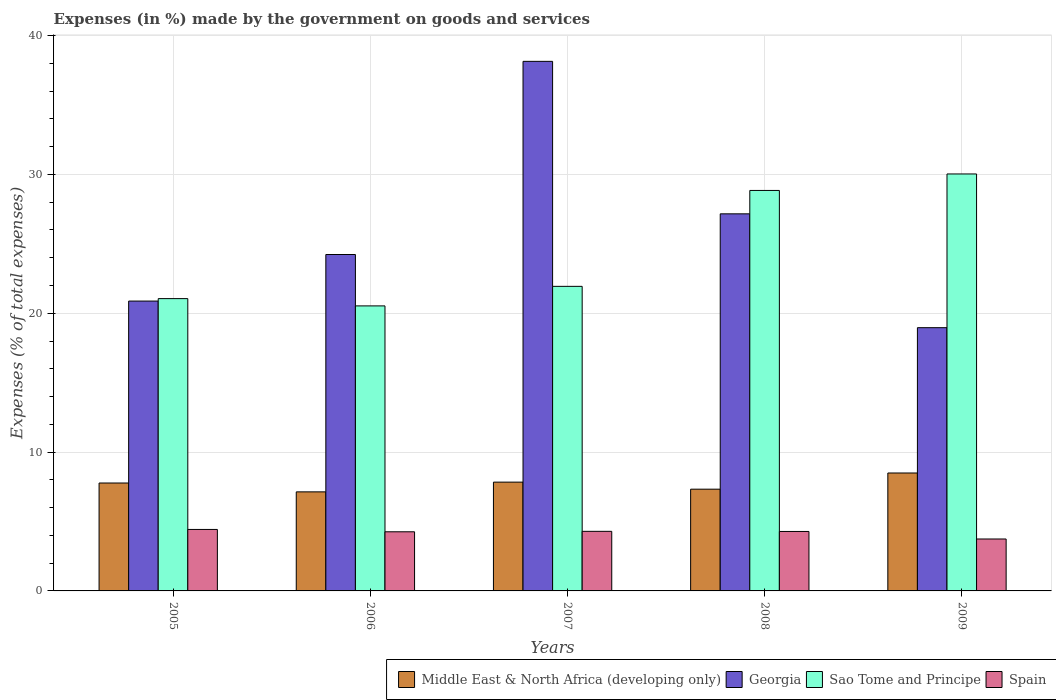How many different coloured bars are there?
Keep it short and to the point. 4. How many bars are there on the 4th tick from the left?
Ensure brevity in your answer.  4. What is the label of the 3rd group of bars from the left?
Your response must be concise. 2007. What is the percentage of expenses made by the government on goods and services in Spain in 2006?
Ensure brevity in your answer.  4.26. Across all years, what is the maximum percentage of expenses made by the government on goods and services in Spain?
Provide a succinct answer. 4.43. Across all years, what is the minimum percentage of expenses made by the government on goods and services in Sao Tome and Principe?
Your answer should be very brief. 20.53. In which year was the percentage of expenses made by the government on goods and services in Georgia maximum?
Keep it short and to the point. 2007. What is the total percentage of expenses made by the government on goods and services in Georgia in the graph?
Offer a terse response. 129.37. What is the difference between the percentage of expenses made by the government on goods and services in Georgia in 2005 and that in 2009?
Give a very brief answer. 1.92. What is the difference between the percentage of expenses made by the government on goods and services in Middle East & North Africa (developing only) in 2008 and the percentage of expenses made by the government on goods and services in Spain in 2006?
Give a very brief answer. 3.07. What is the average percentage of expenses made by the government on goods and services in Middle East & North Africa (developing only) per year?
Your answer should be very brief. 7.71. In the year 2008, what is the difference between the percentage of expenses made by the government on goods and services in Georgia and percentage of expenses made by the government on goods and services in Spain?
Ensure brevity in your answer.  22.88. In how many years, is the percentage of expenses made by the government on goods and services in Sao Tome and Principe greater than 20 %?
Keep it short and to the point. 5. What is the ratio of the percentage of expenses made by the government on goods and services in Middle East & North Africa (developing only) in 2007 to that in 2008?
Provide a short and direct response. 1.07. Is the percentage of expenses made by the government on goods and services in Middle East & North Africa (developing only) in 2005 less than that in 2007?
Your answer should be compact. Yes. What is the difference between the highest and the second highest percentage of expenses made by the government on goods and services in Spain?
Provide a succinct answer. 0.14. What is the difference between the highest and the lowest percentage of expenses made by the government on goods and services in Georgia?
Provide a short and direct response. 19.18. Is the sum of the percentage of expenses made by the government on goods and services in Middle East & North Africa (developing only) in 2007 and 2009 greater than the maximum percentage of expenses made by the government on goods and services in Sao Tome and Principe across all years?
Your response must be concise. No. What does the 1st bar from the left in 2008 represents?
Offer a very short reply. Middle East & North Africa (developing only). What does the 3rd bar from the right in 2007 represents?
Offer a terse response. Georgia. Does the graph contain grids?
Provide a short and direct response. Yes. Where does the legend appear in the graph?
Provide a short and direct response. Bottom right. How are the legend labels stacked?
Your response must be concise. Horizontal. What is the title of the graph?
Your answer should be compact. Expenses (in %) made by the government on goods and services. What is the label or title of the Y-axis?
Offer a terse response. Expenses (% of total expenses). What is the Expenses (% of total expenses) of Middle East & North Africa (developing only) in 2005?
Your answer should be very brief. 7.77. What is the Expenses (% of total expenses) of Georgia in 2005?
Keep it short and to the point. 20.88. What is the Expenses (% of total expenses) in Sao Tome and Principe in 2005?
Ensure brevity in your answer.  21.05. What is the Expenses (% of total expenses) of Spain in 2005?
Offer a very short reply. 4.43. What is the Expenses (% of total expenses) of Middle East & North Africa (developing only) in 2006?
Give a very brief answer. 7.13. What is the Expenses (% of total expenses) in Georgia in 2006?
Ensure brevity in your answer.  24.23. What is the Expenses (% of total expenses) in Sao Tome and Principe in 2006?
Keep it short and to the point. 20.53. What is the Expenses (% of total expenses) of Spain in 2006?
Keep it short and to the point. 4.26. What is the Expenses (% of total expenses) in Middle East & North Africa (developing only) in 2007?
Offer a very short reply. 7.84. What is the Expenses (% of total expenses) in Georgia in 2007?
Keep it short and to the point. 38.14. What is the Expenses (% of total expenses) of Sao Tome and Principe in 2007?
Your answer should be compact. 21.94. What is the Expenses (% of total expenses) in Spain in 2007?
Provide a succinct answer. 4.29. What is the Expenses (% of total expenses) in Middle East & North Africa (developing only) in 2008?
Your response must be concise. 7.33. What is the Expenses (% of total expenses) of Georgia in 2008?
Your response must be concise. 27.16. What is the Expenses (% of total expenses) in Sao Tome and Principe in 2008?
Keep it short and to the point. 28.85. What is the Expenses (% of total expenses) of Spain in 2008?
Keep it short and to the point. 4.28. What is the Expenses (% of total expenses) in Middle East & North Africa (developing only) in 2009?
Provide a short and direct response. 8.49. What is the Expenses (% of total expenses) in Georgia in 2009?
Make the answer very short. 18.96. What is the Expenses (% of total expenses) of Sao Tome and Principe in 2009?
Offer a terse response. 30.03. What is the Expenses (% of total expenses) of Spain in 2009?
Provide a succinct answer. 3.74. Across all years, what is the maximum Expenses (% of total expenses) in Middle East & North Africa (developing only)?
Offer a terse response. 8.49. Across all years, what is the maximum Expenses (% of total expenses) in Georgia?
Your answer should be very brief. 38.14. Across all years, what is the maximum Expenses (% of total expenses) of Sao Tome and Principe?
Offer a terse response. 30.03. Across all years, what is the maximum Expenses (% of total expenses) of Spain?
Offer a very short reply. 4.43. Across all years, what is the minimum Expenses (% of total expenses) of Middle East & North Africa (developing only)?
Provide a short and direct response. 7.13. Across all years, what is the minimum Expenses (% of total expenses) in Georgia?
Your answer should be very brief. 18.96. Across all years, what is the minimum Expenses (% of total expenses) of Sao Tome and Principe?
Offer a very short reply. 20.53. Across all years, what is the minimum Expenses (% of total expenses) of Spain?
Offer a very short reply. 3.74. What is the total Expenses (% of total expenses) in Middle East & North Africa (developing only) in the graph?
Offer a very short reply. 38.57. What is the total Expenses (% of total expenses) in Georgia in the graph?
Provide a short and direct response. 129.37. What is the total Expenses (% of total expenses) in Sao Tome and Principe in the graph?
Offer a terse response. 122.4. What is the total Expenses (% of total expenses) of Spain in the graph?
Your answer should be very brief. 21. What is the difference between the Expenses (% of total expenses) of Middle East & North Africa (developing only) in 2005 and that in 2006?
Offer a terse response. 0.64. What is the difference between the Expenses (% of total expenses) of Georgia in 2005 and that in 2006?
Your response must be concise. -3.35. What is the difference between the Expenses (% of total expenses) of Sao Tome and Principe in 2005 and that in 2006?
Your answer should be very brief. 0.52. What is the difference between the Expenses (% of total expenses) of Spain in 2005 and that in 2006?
Your answer should be very brief. 0.17. What is the difference between the Expenses (% of total expenses) in Middle East & North Africa (developing only) in 2005 and that in 2007?
Your answer should be very brief. -0.06. What is the difference between the Expenses (% of total expenses) in Georgia in 2005 and that in 2007?
Keep it short and to the point. -17.27. What is the difference between the Expenses (% of total expenses) in Sao Tome and Principe in 2005 and that in 2007?
Offer a very short reply. -0.88. What is the difference between the Expenses (% of total expenses) in Spain in 2005 and that in 2007?
Provide a succinct answer. 0.14. What is the difference between the Expenses (% of total expenses) in Middle East & North Africa (developing only) in 2005 and that in 2008?
Give a very brief answer. 0.44. What is the difference between the Expenses (% of total expenses) in Georgia in 2005 and that in 2008?
Your answer should be compact. -6.28. What is the difference between the Expenses (% of total expenses) of Sao Tome and Principe in 2005 and that in 2008?
Offer a terse response. -7.79. What is the difference between the Expenses (% of total expenses) in Spain in 2005 and that in 2008?
Your response must be concise. 0.15. What is the difference between the Expenses (% of total expenses) of Middle East & North Africa (developing only) in 2005 and that in 2009?
Offer a terse response. -0.72. What is the difference between the Expenses (% of total expenses) in Georgia in 2005 and that in 2009?
Offer a terse response. 1.92. What is the difference between the Expenses (% of total expenses) of Sao Tome and Principe in 2005 and that in 2009?
Your answer should be compact. -8.98. What is the difference between the Expenses (% of total expenses) of Spain in 2005 and that in 2009?
Offer a terse response. 0.69. What is the difference between the Expenses (% of total expenses) of Middle East & North Africa (developing only) in 2006 and that in 2007?
Your answer should be compact. -0.7. What is the difference between the Expenses (% of total expenses) of Georgia in 2006 and that in 2007?
Your answer should be very brief. -13.91. What is the difference between the Expenses (% of total expenses) of Sao Tome and Principe in 2006 and that in 2007?
Ensure brevity in your answer.  -1.41. What is the difference between the Expenses (% of total expenses) in Spain in 2006 and that in 2007?
Offer a very short reply. -0.03. What is the difference between the Expenses (% of total expenses) in Middle East & North Africa (developing only) in 2006 and that in 2008?
Make the answer very short. -0.19. What is the difference between the Expenses (% of total expenses) in Georgia in 2006 and that in 2008?
Ensure brevity in your answer.  -2.93. What is the difference between the Expenses (% of total expenses) in Sao Tome and Principe in 2006 and that in 2008?
Provide a short and direct response. -8.32. What is the difference between the Expenses (% of total expenses) in Spain in 2006 and that in 2008?
Keep it short and to the point. -0.02. What is the difference between the Expenses (% of total expenses) of Middle East & North Africa (developing only) in 2006 and that in 2009?
Keep it short and to the point. -1.36. What is the difference between the Expenses (% of total expenses) of Georgia in 2006 and that in 2009?
Your answer should be very brief. 5.27. What is the difference between the Expenses (% of total expenses) in Sao Tome and Principe in 2006 and that in 2009?
Give a very brief answer. -9.5. What is the difference between the Expenses (% of total expenses) in Spain in 2006 and that in 2009?
Your answer should be very brief. 0.52. What is the difference between the Expenses (% of total expenses) in Middle East & North Africa (developing only) in 2007 and that in 2008?
Ensure brevity in your answer.  0.51. What is the difference between the Expenses (% of total expenses) of Georgia in 2007 and that in 2008?
Your answer should be compact. 10.98. What is the difference between the Expenses (% of total expenses) of Sao Tome and Principe in 2007 and that in 2008?
Offer a terse response. -6.91. What is the difference between the Expenses (% of total expenses) in Spain in 2007 and that in 2008?
Your response must be concise. 0.01. What is the difference between the Expenses (% of total expenses) of Middle East & North Africa (developing only) in 2007 and that in 2009?
Ensure brevity in your answer.  -0.66. What is the difference between the Expenses (% of total expenses) of Georgia in 2007 and that in 2009?
Your answer should be very brief. 19.18. What is the difference between the Expenses (% of total expenses) in Sao Tome and Principe in 2007 and that in 2009?
Keep it short and to the point. -8.1. What is the difference between the Expenses (% of total expenses) in Spain in 2007 and that in 2009?
Ensure brevity in your answer.  0.55. What is the difference between the Expenses (% of total expenses) in Middle East & North Africa (developing only) in 2008 and that in 2009?
Your answer should be very brief. -1.17. What is the difference between the Expenses (% of total expenses) of Georgia in 2008 and that in 2009?
Give a very brief answer. 8.2. What is the difference between the Expenses (% of total expenses) in Sao Tome and Principe in 2008 and that in 2009?
Your answer should be compact. -1.19. What is the difference between the Expenses (% of total expenses) of Spain in 2008 and that in 2009?
Ensure brevity in your answer.  0.54. What is the difference between the Expenses (% of total expenses) in Middle East & North Africa (developing only) in 2005 and the Expenses (% of total expenses) in Georgia in 2006?
Offer a very short reply. -16.46. What is the difference between the Expenses (% of total expenses) in Middle East & North Africa (developing only) in 2005 and the Expenses (% of total expenses) in Sao Tome and Principe in 2006?
Give a very brief answer. -12.76. What is the difference between the Expenses (% of total expenses) of Middle East & North Africa (developing only) in 2005 and the Expenses (% of total expenses) of Spain in 2006?
Keep it short and to the point. 3.51. What is the difference between the Expenses (% of total expenses) in Georgia in 2005 and the Expenses (% of total expenses) in Sao Tome and Principe in 2006?
Provide a short and direct response. 0.35. What is the difference between the Expenses (% of total expenses) in Georgia in 2005 and the Expenses (% of total expenses) in Spain in 2006?
Offer a very short reply. 16.62. What is the difference between the Expenses (% of total expenses) in Sao Tome and Principe in 2005 and the Expenses (% of total expenses) in Spain in 2006?
Offer a very short reply. 16.8. What is the difference between the Expenses (% of total expenses) of Middle East & North Africa (developing only) in 2005 and the Expenses (% of total expenses) of Georgia in 2007?
Offer a very short reply. -30.37. What is the difference between the Expenses (% of total expenses) in Middle East & North Africa (developing only) in 2005 and the Expenses (% of total expenses) in Sao Tome and Principe in 2007?
Your answer should be very brief. -14.16. What is the difference between the Expenses (% of total expenses) of Middle East & North Africa (developing only) in 2005 and the Expenses (% of total expenses) of Spain in 2007?
Make the answer very short. 3.48. What is the difference between the Expenses (% of total expenses) in Georgia in 2005 and the Expenses (% of total expenses) in Sao Tome and Principe in 2007?
Provide a short and direct response. -1.06. What is the difference between the Expenses (% of total expenses) in Georgia in 2005 and the Expenses (% of total expenses) in Spain in 2007?
Provide a short and direct response. 16.59. What is the difference between the Expenses (% of total expenses) of Sao Tome and Principe in 2005 and the Expenses (% of total expenses) of Spain in 2007?
Ensure brevity in your answer.  16.76. What is the difference between the Expenses (% of total expenses) in Middle East & North Africa (developing only) in 2005 and the Expenses (% of total expenses) in Georgia in 2008?
Keep it short and to the point. -19.39. What is the difference between the Expenses (% of total expenses) in Middle East & North Africa (developing only) in 2005 and the Expenses (% of total expenses) in Sao Tome and Principe in 2008?
Offer a terse response. -21.07. What is the difference between the Expenses (% of total expenses) of Middle East & North Africa (developing only) in 2005 and the Expenses (% of total expenses) of Spain in 2008?
Your response must be concise. 3.49. What is the difference between the Expenses (% of total expenses) of Georgia in 2005 and the Expenses (% of total expenses) of Sao Tome and Principe in 2008?
Provide a succinct answer. -7.97. What is the difference between the Expenses (% of total expenses) of Georgia in 2005 and the Expenses (% of total expenses) of Spain in 2008?
Your answer should be very brief. 16.59. What is the difference between the Expenses (% of total expenses) of Sao Tome and Principe in 2005 and the Expenses (% of total expenses) of Spain in 2008?
Provide a succinct answer. 16.77. What is the difference between the Expenses (% of total expenses) of Middle East & North Africa (developing only) in 2005 and the Expenses (% of total expenses) of Georgia in 2009?
Give a very brief answer. -11.19. What is the difference between the Expenses (% of total expenses) in Middle East & North Africa (developing only) in 2005 and the Expenses (% of total expenses) in Sao Tome and Principe in 2009?
Provide a succinct answer. -22.26. What is the difference between the Expenses (% of total expenses) of Middle East & North Africa (developing only) in 2005 and the Expenses (% of total expenses) of Spain in 2009?
Give a very brief answer. 4.03. What is the difference between the Expenses (% of total expenses) in Georgia in 2005 and the Expenses (% of total expenses) in Sao Tome and Principe in 2009?
Offer a very short reply. -9.16. What is the difference between the Expenses (% of total expenses) in Georgia in 2005 and the Expenses (% of total expenses) in Spain in 2009?
Provide a succinct answer. 17.14. What is the difference between the Expenses (% of total expenses) in Sao Tome and Principe in 2005 and the Expenses (% of total expenses) in Spain in 2009?
Ensure brevity in your answer.  17.31. What is the difference between the Expenses (% of total expenses) of Middle East & North Africa (developing only) in 2006 and the Expenses (% of total expenses) of Georgia in 2007?
Give a very brief answer. -31.01. What is the difference between the Expenses (% of total expenses) in Middle East & North Africa (developing only) in 2006 and the Expenses (% of total expenses) in Sao Tome and Principe in 2007?
Offer a very short reply. -14.8. What is the difference between the Expenses (% of total expenses) of Middle East & North Africa (developing only) in 2006 and the Expenses (% of total expenses) of Spain in 2007?
Your answer should be compact. 2.84. What is the difference between the Expenses (% of total expenses) in Georgia in 2006 and the Expenses (% of total expenses) in Sao Tome and Principe in 2007?
Provide a succinct answer. 2.29. What is the difference between the Expenses (% of total expenses) of Georgia in 2006 and the Expenses (% of total expenses) of Spain in 2007?
Offer a very short reply. 19.94. What is the difference between the Expenses (% of total expenses) of Sao Tome and Principe in 2006 and the Expenses (% of total expenses) of Spain in 2007?
Provide a succinct answer. 16.24. What is the difference between the Expenses (% of total expenses) in Middle East & North Africa (developing only) in 2006 and the Expenses (% of total expenses) in Georgia in 2008?
Provide a short and direct response. -20.03. What is the difference between the Expenses (% of total expenses) in Middle East & North Africa (developing only) in 2006 and the Expenses (% of total expenses) in Sao Tome and Principe in 2008?
Offer a terse response. -21.71. What is the difference between the Expenses (% of total expenses) in Middle East & North Africa (developing only) in 2006 and the Expenses (% of total expenses) in Spain in 2008?
Ensure brevity in your answer.  2.85. What is the difference between the Expenses (% of total expenses) in Georgia in 2006 and the Expenses (% of total expenses) in Sao Tome and Principe in 2008?
Offer a terse response. -4.61. What is the difference between the Expenses (% of total expenses) of Georgia in 2006 and the Expenses (% of total expenses) of Spain in 2008?
Make the answer very short. 19.95. What is the difference between the Expenses (% of total expenses) in Sao Tome and Principe in 2006 and the Expenses (% of total expenses) in Spain in 2008?
Your response must be concise. 16.25. What is the difference between the Expenses (% of total expenses) in Middle East & North Africa (developing only) in 2006 and the Expenses (% of total expenses) in Georgia in 2009?
Give a very brief answer. -11.83. What is the difference between the Expenses (% of total expenses) of Middle East & North Africa (developing only) in 2006 and the Expenses (% of total expenses) of Sao Tome and Principe in 2009?
Give a very brief answer. -22.9. What is the difference between the Expenses (% of total expenses) of Middle East & North Africa (developing only) in 2006 and the Expenses (% of total expenses) of Spain in 2009?
Offer a very short reply. 3.39. What is the difference between the Expenses (% of total expenses) in Georgia in 2006 and the Expenses (% of total expenses) in Sao Tome and Principe in 2009?
Your response must be concise. -5.8. What is the difference between the Expenses (% of total expenses) of Georgia in 2006 and the Expenses (% of total expenses) of Spain in 2009?
Keep it short and to the point. 20.49. What is the difference between the Expenses (% of total expenses) of Sao Tome and Principe in 2006 and the Expenses (% of total expenses) of Spain in 2009?
Ensure brevity in your answer.  16.79. What is the difference between the Expenses (% of total expenses) of Middle East & North Africa (developing only) in 2007 and the Expenses (% of total expenses) of Georgia in 2008?
Provide a short and direct response. -19.32. What is the difference between the Expenses (% of total expenses) in Middle East & North Africa (developing only) in 2007 and the Expenses (% of total expenses) in Sao Tome and Principe in 2008?
Provide a succinct answer. -21.01. What is the difference between the Expenses (% of total expenses) of Middle East & North Africa (developing only) in 2007 and the Expenses (% of total expenses) of Spain in 2008?
Provide a short and direct response. 3.55. What is the difference between the Expenses (% of total expenses) of Georgia in 2007 and the Expenses (% of total expenses) of Sao Tome and Principe in 2008?
Provide a succinct answer. 9.3. What is the difference between the Expenses (% of total expenses) of Georgia in 2007 and the Expenses (% of total expenses) of Spain in 2008?
Give a very brief answer. 33.86. What is the difference between the Expenses (% of total expenses) of Sao Tome and Principe in 2007 and the Expenses (% of total expenses) of Spain in 2008?
Provide a short and direct response. 17.65. What is the difference between the Expenses (% of total expenses) of Middle East & North Africa (developing only) in 2007 and the Expenses (% of total expenses) of Georgia in 2009?
Offer a terse response. -11.12. What is the difference between the Expenses (% of total expenses) in Middle East & North Africa (developing only) in 2007 and the Expenses (% of total expenses) in Sao Tome and Principe in 2009?
Your response must be concise. -22.2. What is the difference between the Expenses (% of total expenses) of Middle East & North Africa (developing only) in 2007 and the Expenses (% of total expenses) of Spain in 2009?
Your answer should be very brief. 4.1. What is the difference between the Expenses (% of total expenses) in Georgia in 2007 and the Expenses (% of total expenses) in Sao Tome and Principe in 2009?
Make the answer very short. 8.11. What is the difference between the Expenses (% of total expenses) of Georgia in 2007 and the Expenses (% of total expenses) of Spain in 2009?
Provide a short and direct response. 34.4. What is the difference between the Expenses (% of total expenses) of Sao Tome and Principe in 2007 and the Expenses (% of total expenses) of Spain in 2009?
Your response must be concise. 18.2. What is the difference between the Expenses (% of total expenses) in Middle East & North Africa (developing only) in 2008 and the Expenses (% of total expenses) in Georgia in 2009?
Make the answer very short. -11.63. What is the difference between the Expenses (% of total expenses) of Middle East & North Africa (developing only) in 2008 and the Expenses (% of total expenses) of Sao Tome and Principe in 2009?
Give a very brief answer. -22.7. What is the difference between the Expenses (% of total expenses) in Middle East & North Africa (developing only) in 2008 and the Expenses (% of total expenses) in Spain in 2009?
Keep it short and to the point. 3.59. What is the difference between the Expenses (% of total expenses) in Georgia in 2008 and the Expenses (% of total expenses) in Sao Tome and Principe in 2009?
Provide a short and direct response. -2.87. What is the difference between the Expenses (% of total expenses) of Georgia in 2008 and the Expenses (% of total expenses) of Spain in 2009?
Ensure brevity in your answer.  23.42. What is the difference between the Expenses (% of total expenses) of Sao Tome and Principe in 2008 and the Expenses (% of total expenses) of Spain in 2009?
Keep it short and to the point. 25.11. What is the average Expenses (% of total expenses) in Middle East & North Africa (developing only) per year?
Offer a very short reply. 7.71. What is the average Expenses (% of total expenses) in Georgia per year?
Make the answer very short. 25.87. What is the average Expenses (% of total expenses) in Sao Tome and Principe per year?
Provide a succinct answer. 24.48. What is the average Expenses (% of total expenses) in Spain per year?
Your response must be concise. 4.2. In the year 2005, what is the difference between the Expenses (% of total expenses) in Middle East & North Africa (developing only) and Expenses (% of total expenses) in Georgia?
Offer a terse response. -13.1. In the year 2005, what is the difference between the Expenses (% of total expenses) in Middle East & North Africa (developing only) and Expenses (% of total expenses) in Sao Tome and Principe?
Provide a short and direct response. -13.28. In the year 2005, what is the difference between the Expenses (% of total expenses) in Middle East & North Africa (developing only) and Expenses (% of total expenses) in Spain?
Ensure brevity in your answer.  3.35. In the year 2005, what is the difference between the Expenses (% of total expenses) of Georgia and Expenses (% of total expenses) of Sao Tome and Principe?
Your answer should be very brief. -0.18. In the year 2005, what is the difference between the Expenses (% of total expenses) in Georgia and Expenses (% of total expenses) in Spain?
Ensure brevity in your answer.  16.45. In the year 2005, what is the difference between the Expenses (% of total expenses) in Sao Tome and Principe and Expenses (% of total expenses) in Spain?
Give a very brief answer. 16.63. In the year 2006, what is the difference between the Expenses (% of total expenses) of Middle East & North Africa (developing only) and Expenses (% of total expenses) of Georgia?
Your answer should be very brief. -17.1. In the year 2006, what is the difference between the Expenses (% of total expenses) of Middle East & North Africa (developing only) and Expenses (% of total expenses) of Sao Tome and Principe?
Offer a terse response. -13.4. In the year 2006, what is the difference between the Expenses (% of total expenses) in Middle East & North Africa (developing only) and Expenses (% of total expenses) in Spain?
Keep it short and to the point. 2.88. In the year 2006, what is the difference between the Expenses (% of total expenses) in Georgia and Expenses (% of total expenses) in Sao Tome and Principe?
Give a very brief answer. 3.7. In the year 2006, what is the difference between the Expenses (% of total expenses) in Georgia and Expenses (% of total expenses) in Spain?
Make the answer very short. 19.97. In the year 2006, what is the difference between the Expenses (% of total expenses) in Sao Tome and Principe and Expenses (% of total expenses) in Spain?
Provide a succinct answer. 16.27. In the year 2007, what is the difference between the Expenses (% of total expenses) of Middle East & North Africa (developing only) and Expenses (% of total expenses) of Georgia?
Keep it short and to the point. -30.31. In the year 2007, what is the difference between the Expenses (% of total expenses) in Middle East & North Africa (developing only) and Expenses (% of total expenses) in Sao Tome and Principe?
Provide a short and direct response. -14.1. In the year 2007, what is the difference between the Expenses (% of total expenses) of Middle East & North Africa (developing only) and Expenses (% of total expenses) of Spain?
Offer a terse response. 3.54. In the year 2007, what is the difference between the Expenses (% of total expenses) of Georgia and Expenses (% of total expenses) of Sao Tome and Principe?
Make the answer very short. 16.21. In the year 2007, what is the difference between the Expenses (% of total expenses) in Georgia and Expenses (% of total expenses) in Spain?
Ensure brevity in your answer.  33.85. In the year 2007, what is the difference between the Expenses (% of total expenses) of Sao Tome and Principe and Expenses (% of total expenses) of Spain?
Provide a succinct answer. 17.65. In the year 2008, what is the difference between the Expenses (% of total expenses) in Middle East & North Africa (developing only) and Expenses (% of total expenses) in Georgia?
Offer a terse response. -19.83. In the year 2008, what is the difference between the Expenses (% of total expenses) in Middle East & North Africa (developing only) and Expenses (% of total expenses) in Sao Tome and Principe?
Ensure brevity in your answer.  -21.52. In the year 2008, what is the difference between the Expenses (% of total expenses) of Middle East & North Africa (developing only) and Expenses (% of total expenses) of Spain?
Ensure brevity in your answer.  3.05. In the year 2008, what is the difference between the Expenses (% of total expenses) in Georgia and Expenses (% of total expenses) in Sao Tome and Principe?
Keep it short and to the point. -1.68. In the year 2008, what is the difference between the Expenses (% of total expenses) of Georgia and Expenses (% of total expenses) of Spain?
Offer a very short reply. 22.88. In the year 2008, what is the difference between the Expenses (% of total expenses) in Sao Tome and Principe and Expenses (% of total expenses) in Spain?
Make the answer very short. 24.56. In the year 2009, what is the difference between the Expenses (% of total expenses) in Middle East & North Africa (developing only) and Expenses (% of total expenses) in Georgia?
Your answer should be compact. -10.47. In the year 2009, what is the difference between the Expenses (% of total expenses) of Middle East & North Africa (developing only) and Expenses (% of total expenses) of Sao Tome and Principe?
Your answer should be compact. -21.54. In the year 2009, what is the difference between the Expenses (% of total expenses) of Middle East & North Africa (developing only) and Expenses (% of total expenses) of Spain?
Your answer should be compact. 4.75. In the year 2009, what is the difference between the Expenses (% of total expenses) in Georgia and Expenses (% of total expenses) in Sao Tome and Principe?
Keep it short and to the point. -11.07. In the year 2009, what is the difference between the Expenses (% of total expenses) of Georgia and Expenses (% of total expenses) of Spain?
Make the answer very short. 15.22. In the year 2009, what is the difference between the Expenses (% of total expenses) in Sao Tome and Principe and Expenses (% of total expenses) in Spain?
Offer a terse response. 26.29. What is the ratio of the Expenses (% of total expenses) in Middle East & North Africa (developing only) in 2005 to that in 2006?
Your answer should be compact. 1.09. What is the ratio of the Expenses (% of total expenses) in Georgia in 2005 to that in 2006?
Provide a succinct answer. 0.86. What is the ratio of the Expenses (% of total expenses) of Sao Tome and Principe in 2005 to that in 2006?
Give a very brief answer. 1.03. What is the ratio of the Expenses (% of total expenses) in Spain in 2005 to that in 2006?
Provide a short and direct response. 1.04. What is the ratio of the Expenses (% of total expenses) of Middle East & North Africa (developing only) in 2005 to that in 2007?
Give a very brief answer. 0.99. What is the ratio of the Expenses (% of total expenses) of Georgia in 2005 to that in 2007?
Offer a terse response. 0.55. What is the ratio of the Expenses (% of total expenses) in Sao Tome and Principe in 2005 to that in 2007?
Offer a very short reply. 0.96. What is the ratio of the Expenses (% of total expenses) in Spain in 2005 to that in 2007?
Offer a terse response. 1.03. What is the ratio of the Expenses (% of total expenses) of Middle East & North Africa (developing only) in 2005 to that in 2008?
Your response must be concise. 1.06. What is the ratio of the Expenses (% of total expenses) of Georgia in 2005 to that in 2008?
Your answer should be compact. 0.77. What is the ratio of the Expenses (% of total expenses) of Sao Tome and Principe in 2005 to that in 2008?
Ensure brevity in your answer.  0.73. What is the ratio of the Expenses (% of total expenses) of Spain in 2005 to that in 2008?
Provide a succinct answer. 1.03. What is the ratio of the Expenses (% of total expenses) in Middle East & North Africa (developing only) in 2005 to that in 2009?
Offer a terse response. 0.92. What is the ratio of the Expenses (% of total expenses) in Georgia in 2005 to that in 2009?
Make the answer very short. 1.1. What is the ratio of the Expenses (% of total expenses) of Sao Tome and Principe in 2005 to that in 2009?
Your answer should be very brief. 0.7. What is the ratio of the Expenses (% of total expenses) in Spain in 2005 to that in 2009?
Provide a succinct answer. 1.18. What is the ratio of the Expenses (% of total expenses) of Middle East & North Africa (developing only) in 2006 to that in 2007?
Offer a terse response. 0.91. What is the ratio of the Expenses (% of total expenses) in Georgia in 2006 to that in 2007?
Your response must be concise. 0.64. What is the ratio of the Expenses (% of total expenses) of Sao Tome and Principe in 2006 to that in 2007?
Your answer should be compact. 0.94. What is the ratio of the Expenses (% of total expenses) in Spain in 2006 to that in 2007?
Offer a very short reply. 0.99. What is the ratio of the Expenses (% of total expenses) of Middle East & North Africa (developing only) in 2006 to that in 2008?
Give a very brief answer. 0.97. What is the ratio of the Expenses (% of total expenses) in Georgia in 2006 to that in 2008?
Your answer should be very brief. 0.89. What is the ratio of the Expenses (% of total expenses) of Sao Tome and Principe in 2006 to that in 2008?
Ensure brevity in your answer.  0.71. What is the ratio of the Expenses (% of total expenses) of Spain in 2006 to that in 2008?
Provide a short and direct response. 0.99. What is the ratio of the Expenses (% of total expenses) in Middle East & North Africa (developing only) in 2006 to that in 2009?
Your answer should be very brief. 0.84. What is the ratio of the Expenses (% of total expenses) of Georgia in 2006 to that in 2009?
Keep it short and to the point. 1.28. What is the ratio of the Expenses (% of total expenses) in Sao Tome and Principe in 2006 to that in 2009?
Your answer should be very brief. 0.68. What is the ratio of the Expenses (% of total expenses) of Spain in 2006 to that in 2009?
Your answer should be very brief. 1.14. What is the ratio of the Expenses (% of total expenses) of Middle East & North Africa (developing only) in 2007 to that in 2008?
Your answer should be compact. 1.07. What is the ratio of the Expenses (% of total expenses) of Georgia in 2007 to that in 2008?
Offer a very short reply. 1.4. What is the ratio of the Expenses (% of total expenses) in Sao Tome and Principe in 2007 to that in 2008?
Provide a short and direct response. 0.76. What is the ratio of the Expenses (% of total expenses) of Spain in 2007 to that in 2008?
Make the answer very short. 1. What is the ratio of the Expenses (% of total expenses) in Middle East & North Africa (developing only) in 2007 to that in 2009?
Provide a short and direct response. 0.92. What is the ratio of the Expenses (% of total expenses) of Georgia in 2007 to that in 2009?
Make the answer very short. 2.01. What is the ratio of the Expenses (% of total expenses) in Sao Tome and Principe in 2007 to that in 2009?
Make the answer very short. 0.73. What is the ratio of the Expenses (% of total expenses) in Spain in 2007 to that in 2009?
Give a very brief answer. 1.15. What is the ratio of the Expenses (% of total expenses) of Middle East & North Africa (developing only) in 2008 to that in 2009?
Your answer should be very brief. 0.86. What is the ratio of the Expenses (% of total expenses) in Georgia in 2008 to that in 2009?
Give a very brief answer. 1.43. What is the ratio of the Expenses (% of total expenses) in Sao Tome and Principe in 2008 to that in 2009?
Offer a terse response. 0.96. What is the ratio of the Expenses (% of total expenses) of Spain in 2008 to that in 2009?
Offer a very short reply. 1.15. What is the difference between the highest and the second highest Expenses (% of total expenses) of Middle East & North Africa (developing only)?
Your answer should be compact. 0.66. What is the difference between the highest and the second highest Expenses (% of total expenses) in Georgia?
Provide a short and direct response. 10.98. What is the difference between the highest and the second highest Expenses (% of total expenses) of Sao Tome and Principe?
Your answer should be very brief. 1.19. What is the difference between the highest and the second highest Expenses (% of total expenses) of Spain?
Give a very brief answer. 0.14. What is the difference between the highest and the lowest Expenses (% of total expenses) in Middle East & North Africa (developing only)?
Provide a succinct answer. 1.36. What is the difference between the highest and the lowest Expenses (% of total expenses) in Georgia?
Offer a very short reply. 19.18. What is the difference between the highest and the lowest Expenses (% of total expenses) in Sao Tome and Principe?
Make the answer very short. 9.5. What is the difference between the highest and the lowest Expenses (% of total expenses) in Spain?
Offer a terse response. 0.69. 